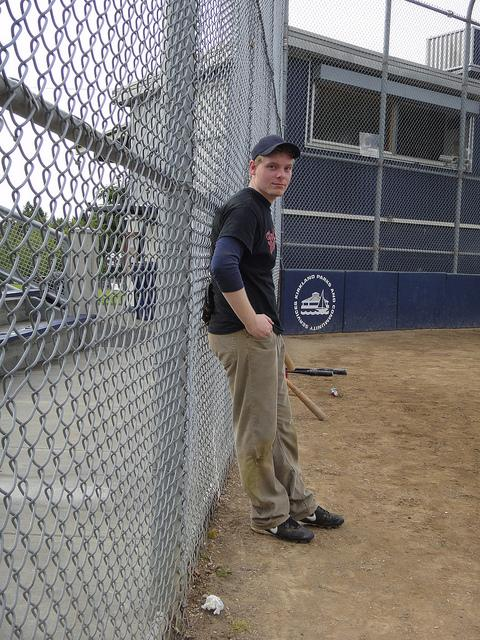What is he doing? Please explain your reasoning. posing. He's technically not actively doing b although he's likely there for that reason. the other two obviously don't apply. 